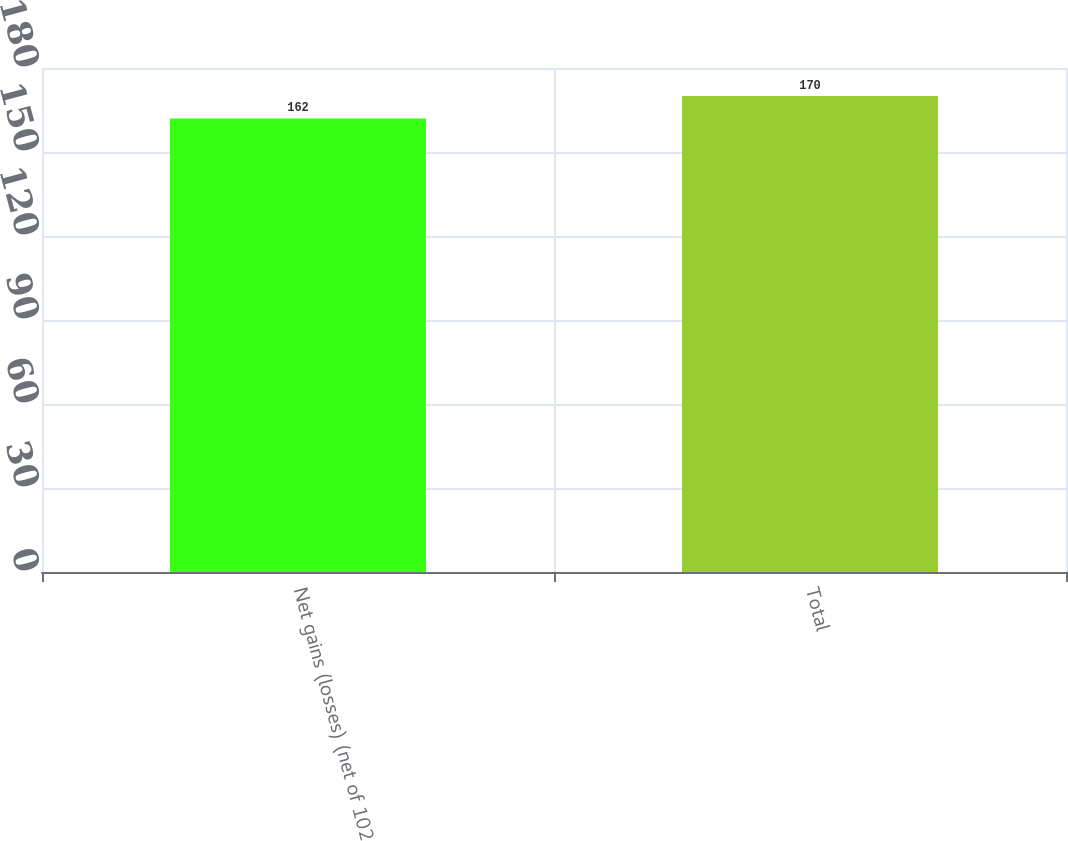Convert chart to OTSL. <chart><loc_0><loc_0><loc_500><loc_500><bar_chart><fcel>Net gains (losses) (net of 102<fcel>Total<nl><fcel>162<fcel>170<nl></chart> 